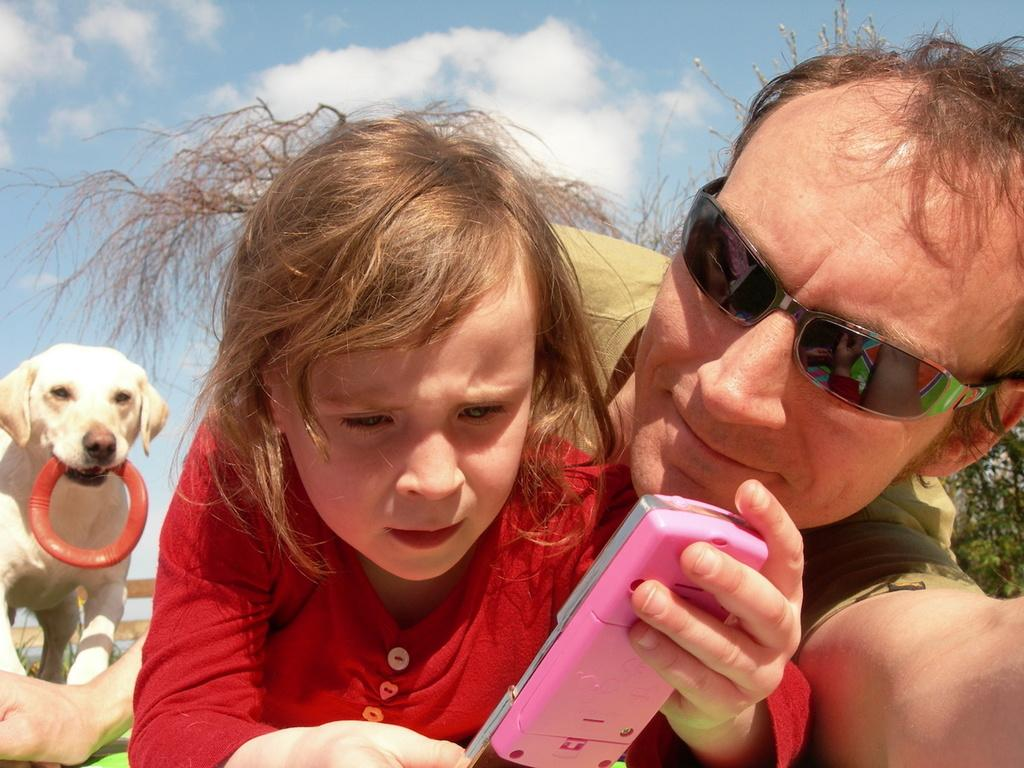What is the main subject of the image? There is a man in the image. What is the girl in the image doing? There is a girl laying in the image. What is the other girl holding in her hand? Another girl is holding an object in her hand. Can you describe the background of the image? There is a dog in the background of the image. What is the dog doing in the image? The dog is holding a wheel. What is visible in the sky in the image? The sky is visible in the image. How does the man express his disgust in the image? There is no indication of disgust in the image; the man's expression or actions are not described. Can you hear the girl coughing in the image? The image is silent, and there is no sound or indication of coughing. 